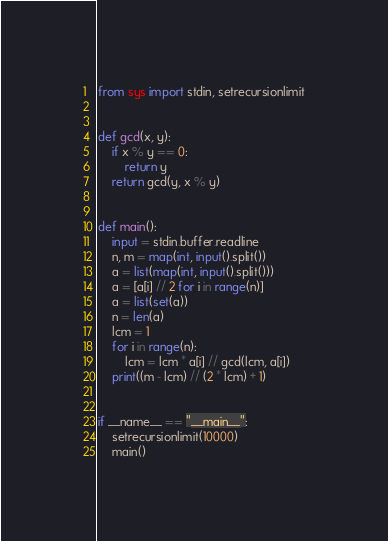<code> <loc_0><loc_0><loc_500><loc_500><_Python_>from sys import stdin, setrecursionlimit


def gcd(x, y):
    if x % y == 0:
        return y
    return gcd(y, x % y)


def main():
    input = stdin.buffer.readline
    n, m = map(int, input().split())
    a = list(map(int, input().split()))
    a = [a[i] // 2 for i in range(n)]
    a = list(set(a))
    n = len(a)
    lcm = 1
    for i in range(n):
        lcm = lcm * a[i] // gcd(lcm, a[i])
    print((m - lcm) // (2 * lcm) + 1)


if __name__ == "__main__":
    setrecursionlimit(10000)
    main()
</code> 